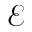Convert formula to latex. <formula><loc_0><loc_0><loc_500><loc_500>\mathcal { E }</formula> 